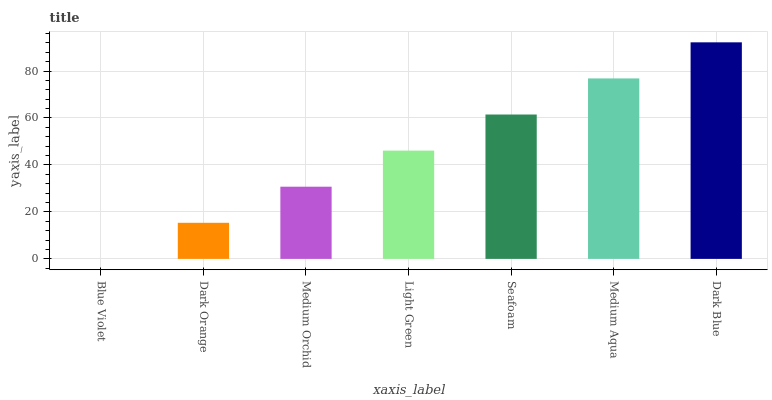Is Blue Violet the minimum?
Answer yes or no. Yes. Is Dark Blue the maximum?
Answer yes or no. Yes. Is Dark Orange the minimum?
Answer yes or no. No. Is Dark Orange the maximum?
Answer yes or no. No. Is Dark Orange greater than Blue Violet?
Answer yes or no. Yes. Is Blue Violet less than Dark Orange?
Answer yes or no. Yes. Is Blue Violet greater than Dark Orange?
Answer yes or no. No. Is Dark Orange less than Blue Violet?
Answer yes or no. No. Is Light Green the high median?
Answer yes or no. Yes. Is Light Green the low median?
Answer yes or no. Yes. Is Seafoam the high median?
Answer yes or no. No. Is Medium Aqua the low median?
Answer yes or no. No. 